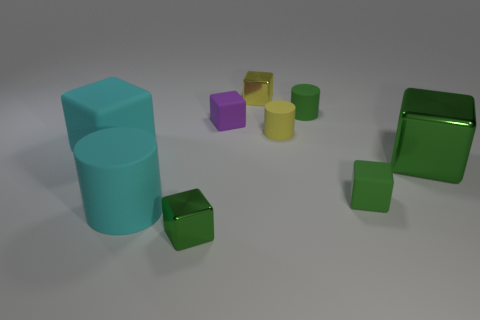Subtract all tiny rubber cubes. How many cubes are left? 4 Subtract all red spheres. How many green blocks are left? 3 Subtract all green blocks. How many blocks are left? 3 Add 1 small red metal things. How many objects exist? 10 Subtract 1 cylinders. How many cylinders are left? 2 Subtract 0 red blocks. How many objects are left? 9 Subtract all cubes. How many objects are left? 3 Subtract all purple cylinders. Subtract all red cubes. How many cylinders are left? 3 Subtract all yellow matte things. Subtract all small green metallic cubes. How many objects are left? 7 Add 4 cyan cubes. How many cyan cubes are left? 5 